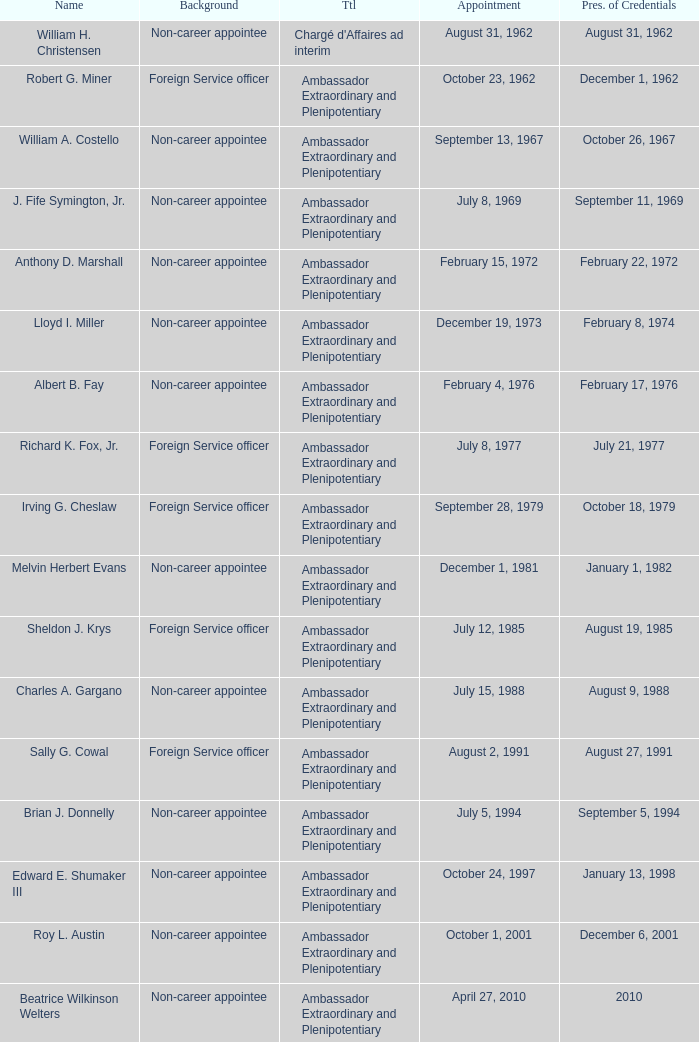Who presented their credentials at an unknown date? Margaret B. Diop. 